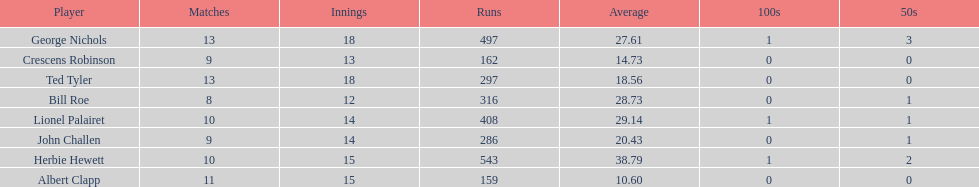What is the least about of runs anyone has? 159. 